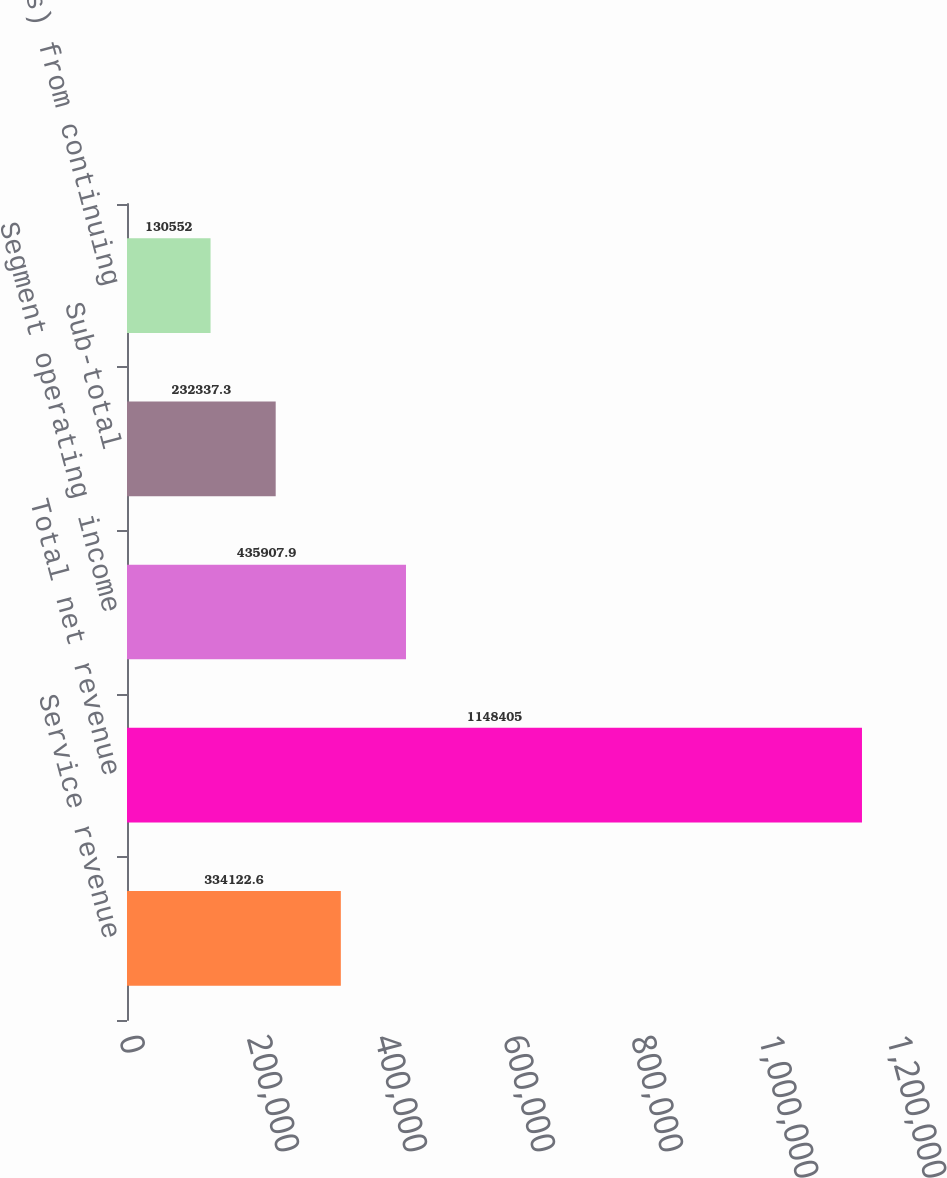<chart> <loc_0><loc_0><loc_500><loc_500><bar_chart><fcel>Service revenue<fcel>Total net revenue<fcel>Segment operating income<fcel>Sub-total<fcel>Income (loss) from continuing<nl><fcel>334123<fcel>1.1484e+06<fcel>435908<fcel>232337<fcel>130552<nl></chart> 